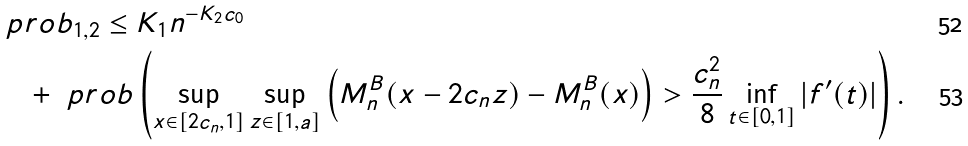<formula> <loc_0><loc_0><loc_500><loc_500>& \ p r o b _ { 1 , 2 } \leq K _ { 1 } n ^ { - K _ { 2 } c _ { 0 } } \\ & \quad + \ p r o b \left ( \sup _ { x \in [ 2 c _ { n } , 1 ] } \sup _ { z \in [ 1 , a ] } \left ( M _ { n } ^ { B } ( x - 2 c _ { n } z ) - M _ { n } ^ { B } ( x ) \right ) > \frac { c _ { n } ^ { 2 } } 8 \inf _ { t \in [ 0 , 1 ] } | f ^ { \prime } ( t ) | \right ) .</formula> 